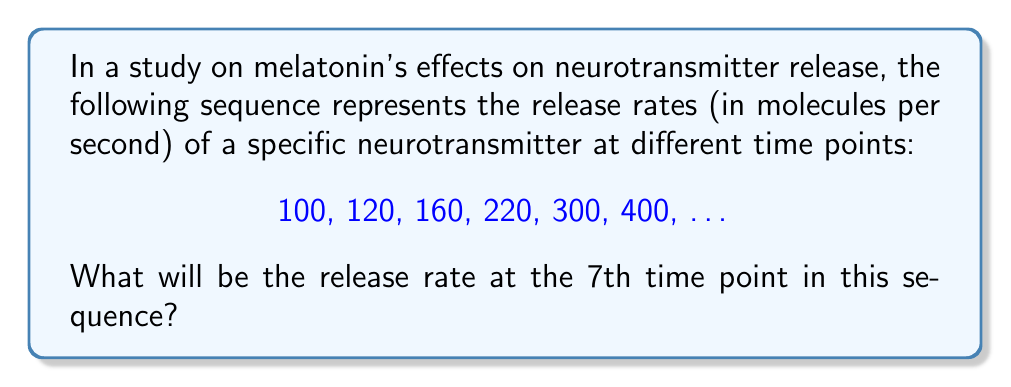Can you solve this math problem? To solve this problem, we need to identify the pattern in the sequence. Let's analyze the differences between consecutive terms:

1) From 100 to 120: Difference = 20
2) From 120 to 160: Difference = 40
3) From 160 to 220: Difference = 60
4) From 220 to 300: Difference = 80
5) From 300 to 400: Difference = 100

We can observe that the difference between consecutive terms is increasing by 20 each time. This forms an arithmetic sequence of differences: 20, 40, 60, 80, 100, ...

To find the next term in the original sequence, we need to add the next difference to the last known term. The next difference would be 120 (following the pattern of increasing by 20).

Therefore:
$$400 + 120 = 520$$

This gives us the 7th term in the sequence.

To verify, let's write out the full sequence:
$$100, 120, 160, 220, 300, 400, 520$$

The pattern holds true for all terms, confirming our solution.
Answer: 520 molecules per second 